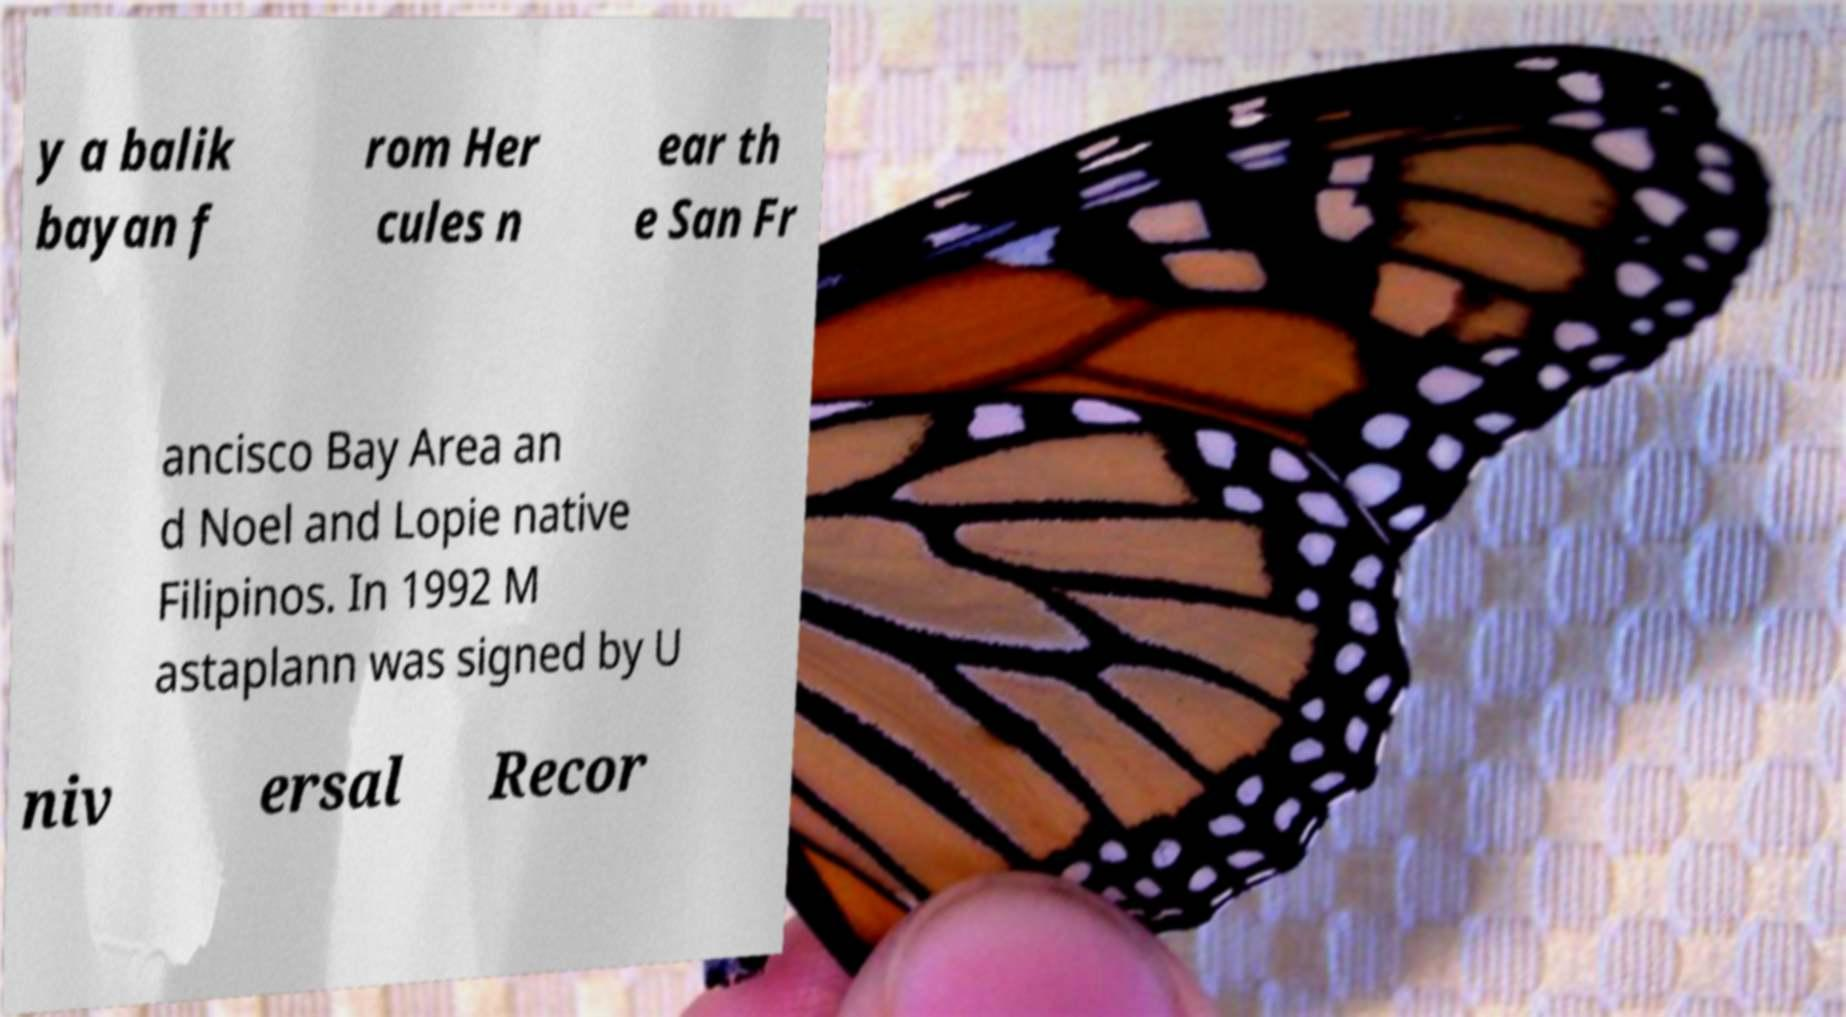Could you assist in decoding the text presented in this image and type it out clearly? y a balik bayan f rom Her cules n ear th e San Fr ancisco Bay Area an d Noel and Lopie native Filipinos. In 1992 M astaplann was signed by U niv ersal Recor 